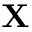Convert formula to latex. <formula><loc_0><loc_0><loc_500><loc_500>X</formula> 